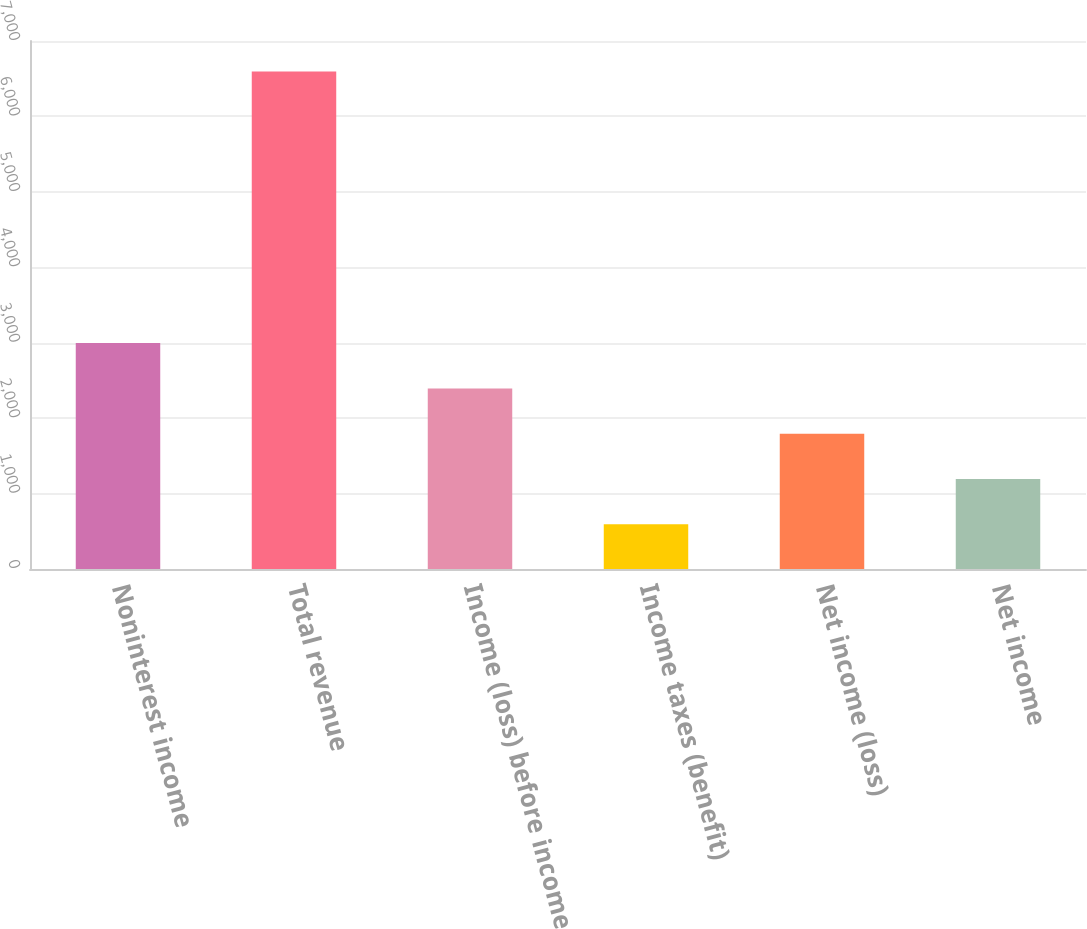<chart> <loc_0><loc_0><loc_500><loc_500><bar_chart><fcel>Noninterest income<fcel>Total revenue<fcel>Income (loss) before income<fcel>Income taxes (benefit)<fcel>Net income (loss)<fcel>Net income<nl><fcel>2994.6<fcel>6597<fcel>2394.2<fcel>593<fcel>1793.8<fcel>1193.4<nl></chart> 